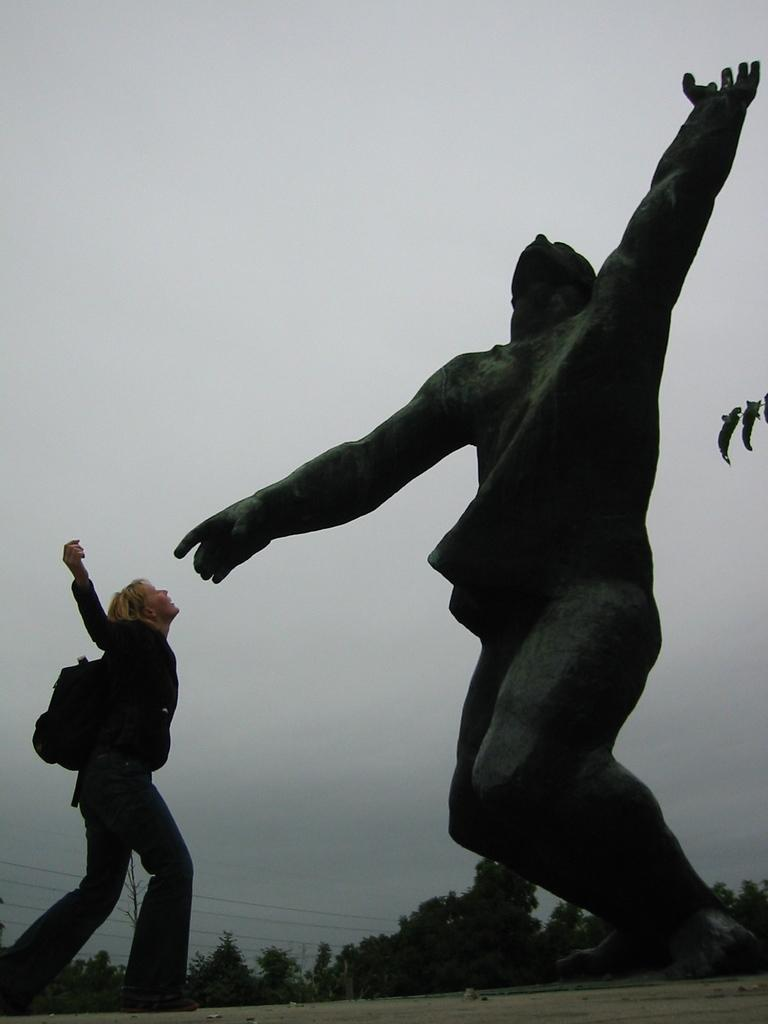What can be seen on the right side of the image? There is a statue on the right side of the image. What is the lady on the left side of the image doing? The lady is standing on the left side of the image. What is the lady carrying on her back? The lady is wearing a backpack. What type of natural scenery is visible in the background of the image? There are trees in the background of the image. What part of the natural environment is visible in the background of the image? The sky is visible in the background of the image. How does the lady guide the pail through the trees in the image? There is no pail present in the image, and the lady is not guiding anything through the trees. 